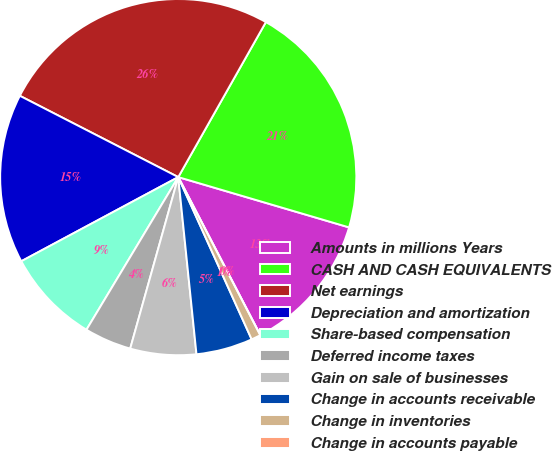<chart> <loc_0><loc_0><loc_500><loc_500><pie_chart><fcel>Amounts in millions Years<fcel>CASH AND CASH EQUIVALENTS<fcel>Net earnings<fcel>Depreciation and amortization<fcel>Share-based compensation<fcel>Deferred income taxes<fcel>Gain on sale of businesses<fcel>Change in accounts receivable<fcel>Change in inventories<fcel>Change in accounts payable<nl><fcel>12.82%<fcel>21.37%<fcel>25.64%<fcel>15.38%<fcel>8.55%<fcel>4.27%<fcel>5.98%<fcel>5.13%<fcel>0.86%<fcel>0.0%<nl></chart> 